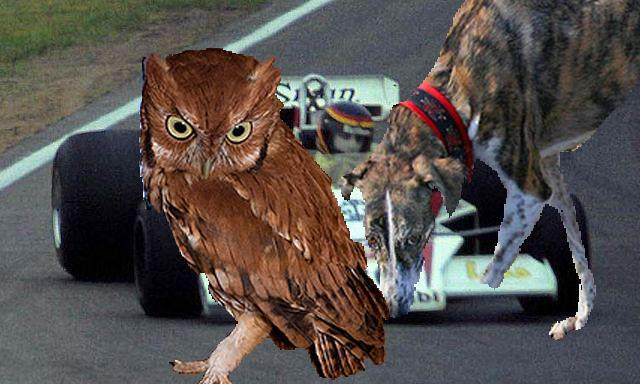How many unicorns are there in the image? 0 